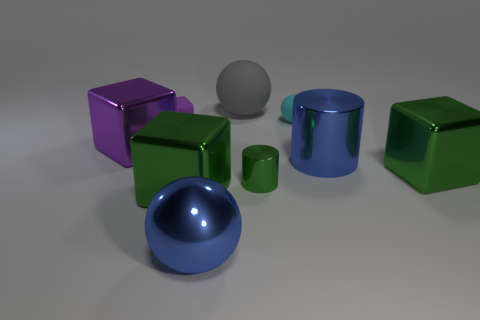Is the color of the shiny ball the same as the large shiny cylinder?
Provide a succinct answer. Yes. What material is the large sphere that is behind the tiny cyan matte sphere?
Provide a succinct answer. Rubber. There is a purple shiny object that is to the left of the cyan rubber object; is its shape the same as the green shiny thing left of the big matte object?
Your answer should be very brief. Yes. Are any big blue rubber cylinders visible?
Keep it short and to the point. No. There is a small object that is the same shape as the large rubber thing; what is it made of?
Provide a short and direct response. Rubber. There is a metallic ball; are there any purple shiny blocks right of it?
Give a very brief answer. No. Is the material of the big cube that is on the right side of the big blue cylinder the same as the blue cylinder?
Provide a short and direct response. Yes. Are there any other big blocks that have the same color as the rubber cube?
Provide a succinct answer. Yes. What is the shape of the big gray rubber thing?
Keep it short and to the point. Sphere. There is a block that is left of the purple block right of the big purple metallic thing; what color is it?
Make the answer very short. Purple. 